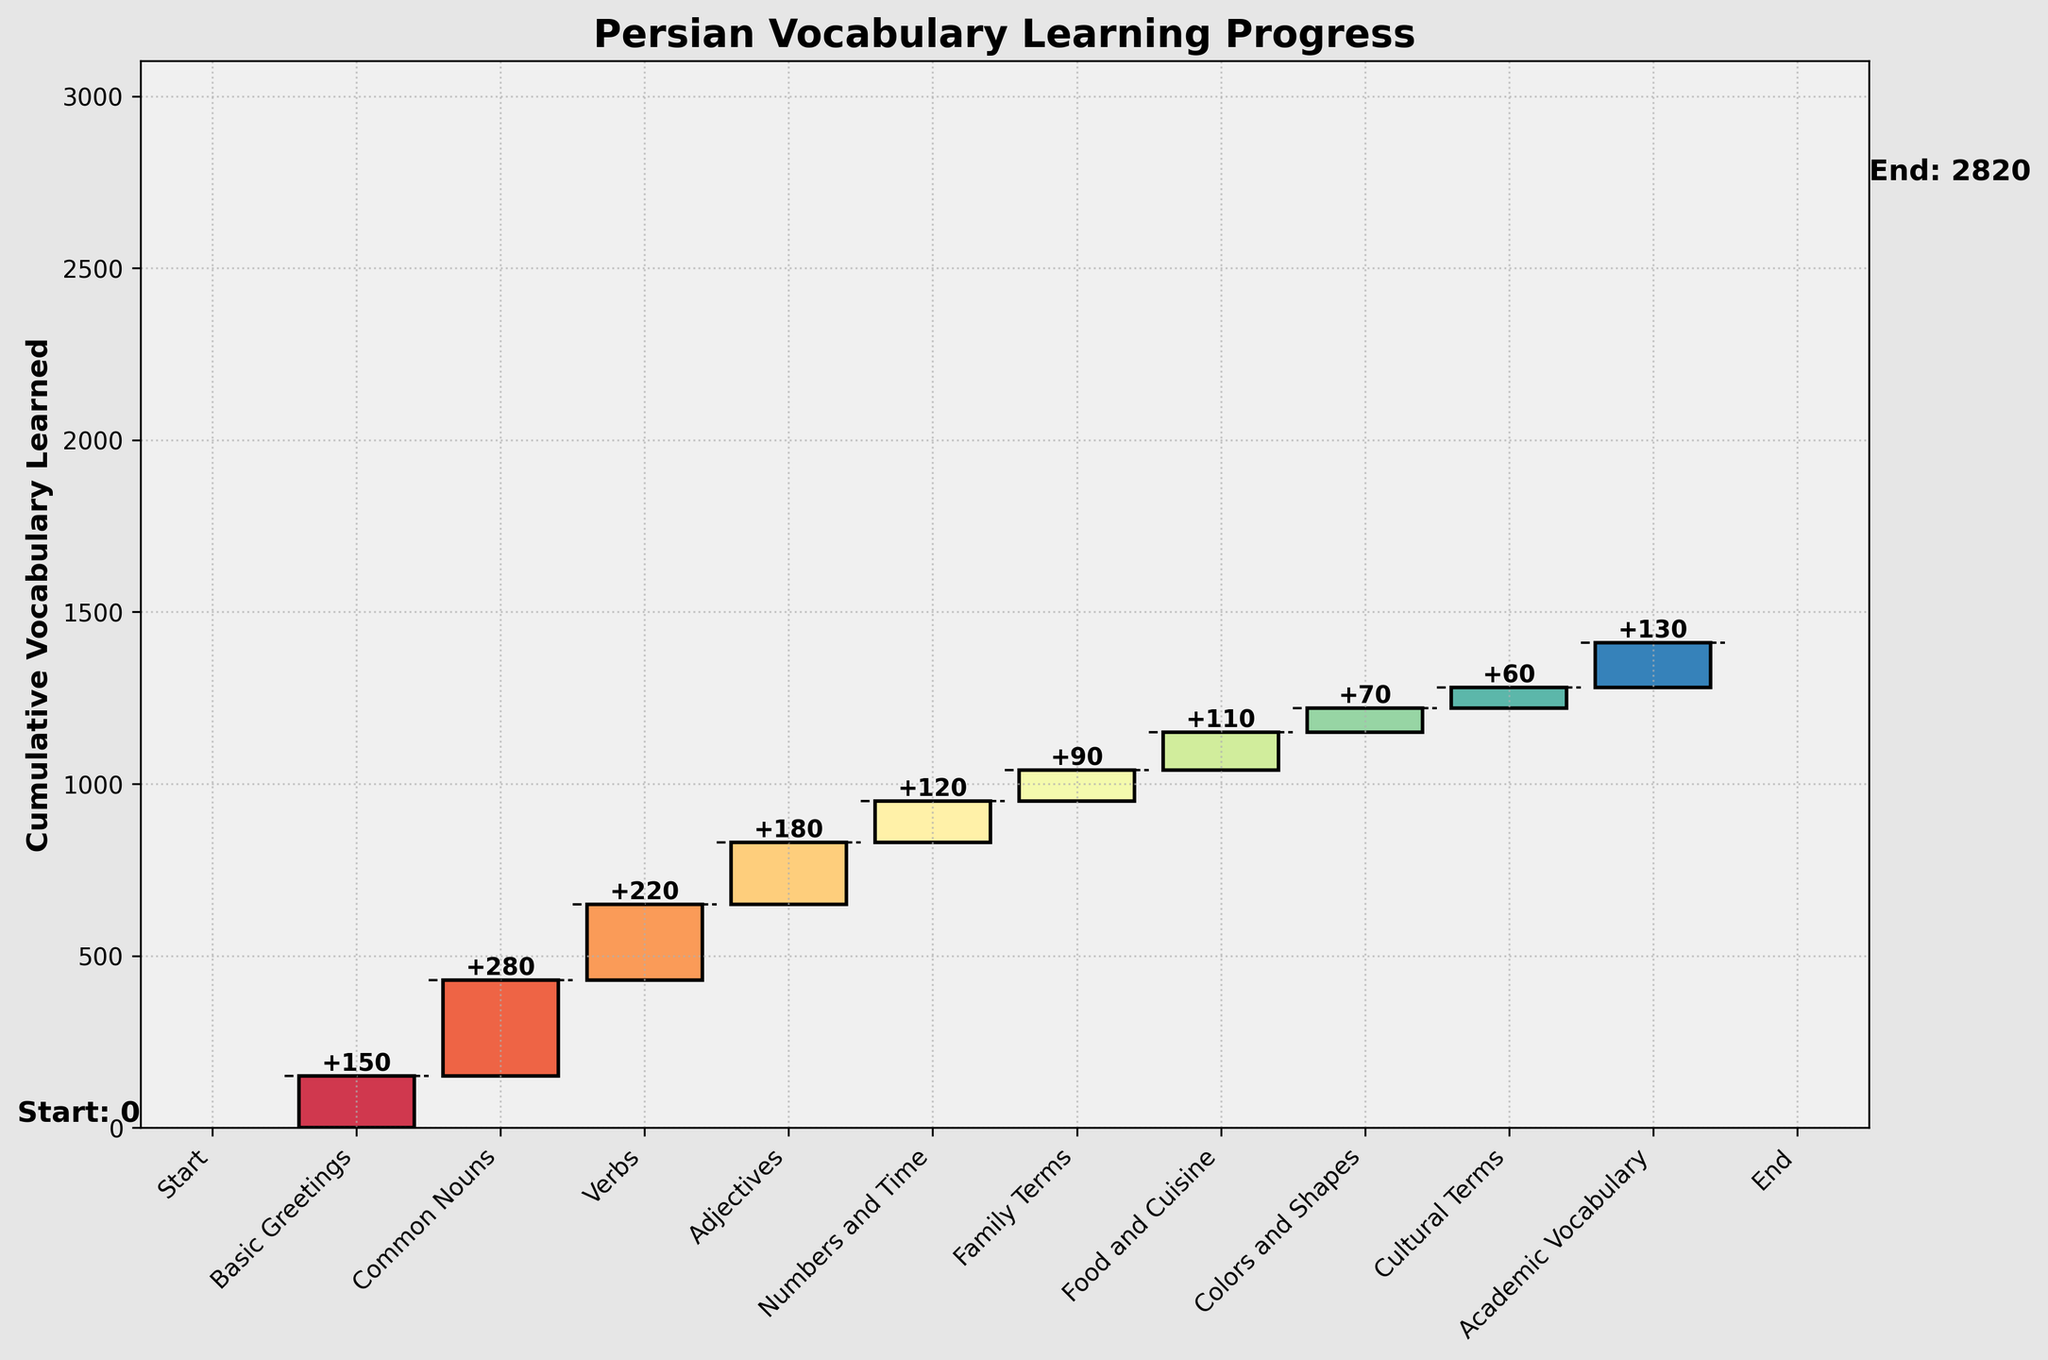How many linguistic categories are displayed in the chart? The chart shows each linguistic category as a bar. To find the number of categories displayed, count each bar. "Start" and "End" are markers, so they should not be included in the count. There are 10 linguistic categories based on the bars: Basic Greetings, Common Nouns, Verbs, Adjectives, Numbers and Time, Family Terms, Food and Cuisine, Colors and Shapes, Cultural Terms, and Academic Vocabulary.
Answer: 10 What is the title of the waterfall chart? The title is found at the top of the chart, typically highlighted in bold text. It summarizes the purpose of the chart. The title is "Persian Vocabulary Learning Progress".
Answer: Persian Vocabulary Learning Progress What is the cumulative total of vocabulary learned by the end of the six-month period? The cumulative total at the end is indicated by the last bar labeled "End" on the chart. The value is directly shown as 1410.
Answer: 1410 By how much did the "Common Nouns" category contribute to the total vocabulary learned? "Common Nouns" has its own specific bar in the chart. The numerical contribution is usually indicated directly on the bar. For "Common Nouns", it shows a contribution of 280.
Answer: 280 What category had the smallest contribution to vocabulary learned? The smallest category contribution can be determined by comparing the height of all bars except the "Start" and "End". "Cultural Terms" has the smallest visible bar with a contribution of 60.
Answer: Cultural Terms What is the combined total contribution of "Family Terms" and "Food and Cuisine"? Find the values for "Family Terms" (90) and "Food and Cuisine" (110) from their respective bars. Add these values: 90 + 110 = 200.
Answer: 200 Which category contributed more: "Adjectives" or "Verbs"? Compare the heights of the bars for "Adjectives" and "Verbs". "Adjectives" contributed 180, whereas "Verbs" contributed 220. "Verbs" have a greater contribution.
Answer: Verbs What is the difference in contribution between "Basic Greetings" and "Numbers and Time"? Subtract the value of "Numbers and Time" (120) from "Basic Greetings" (150). The difference is 150 - 120 = 30.
Answer: 30 How many vocabulary terms were learned in the middle (5th category) of the learning period? The middle category can be found by identifying the 5th bar from the left (excluding "Start"). The category is "Numbers and Time" with a contribution of 120.
Answer: 120 What is the average contribution of all the categories (excluding "Start" and "End")? Calculate the sum of the contributions of all categories and then divide by the number of categories (10). (150 + 280 + 220 + 180 + 120 + 90 + 110 + 70 + 60 + 130) / 10 = 1410 / 10 = 141.
Answer: 141 